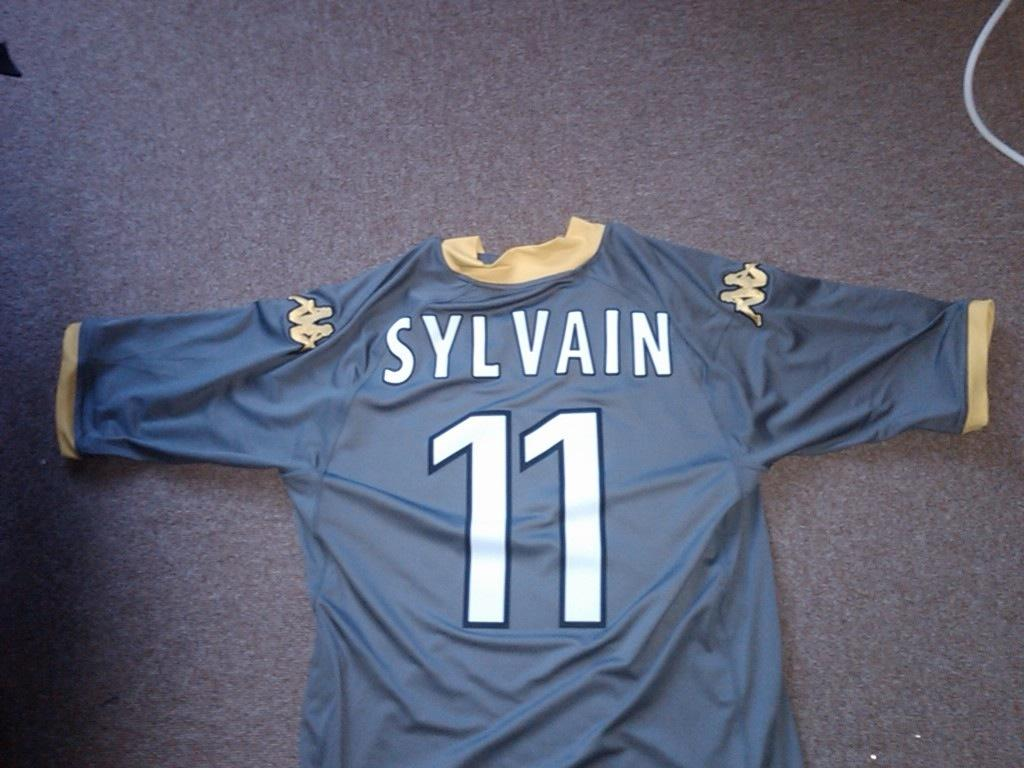<image>
Describe the image concisely. A blue jersey shows the text 'SYLVAIN' and the number 11. 